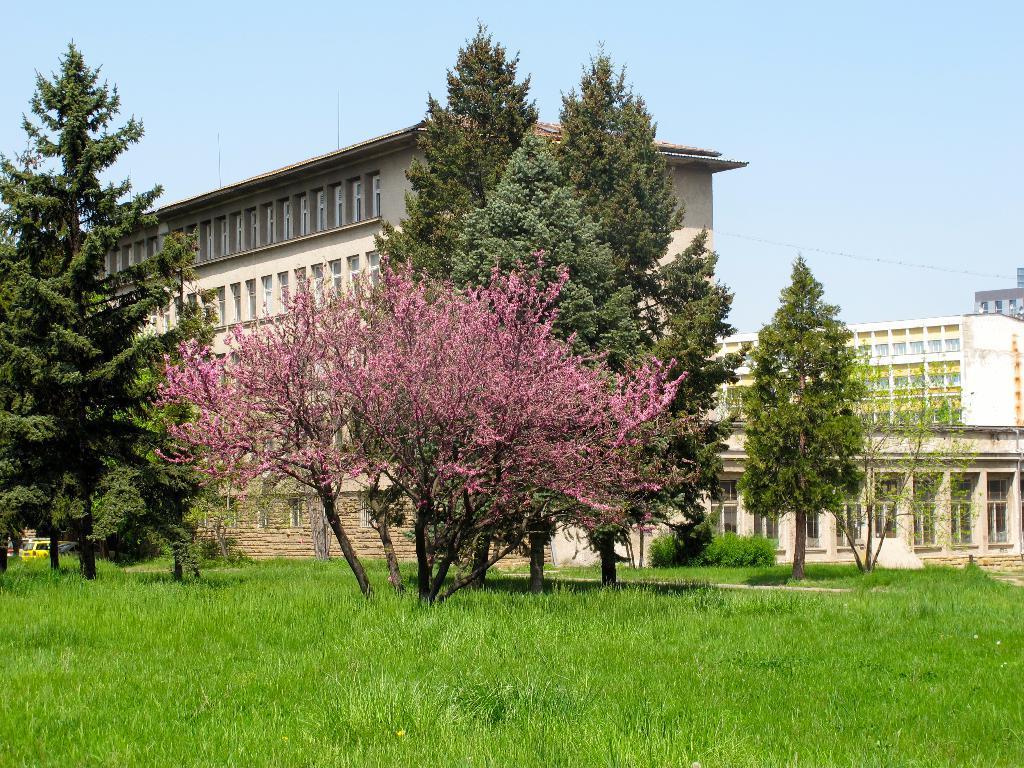How would you summarize this image in a sentence or two? In this image there is a ground at the bottom on which there is grass. In the background there is a building. In front of the building there are plants with pink color leaves. On the right side there are few other buildings. In front of them there are trees. At the top there is the sky. 